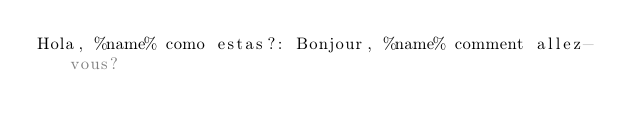<code> <loc_0><loc_0><loc_500><loc_500><_YAML_>Hola, %name% como estas?: Bonjour, %name% comment allez-vous?</code> 